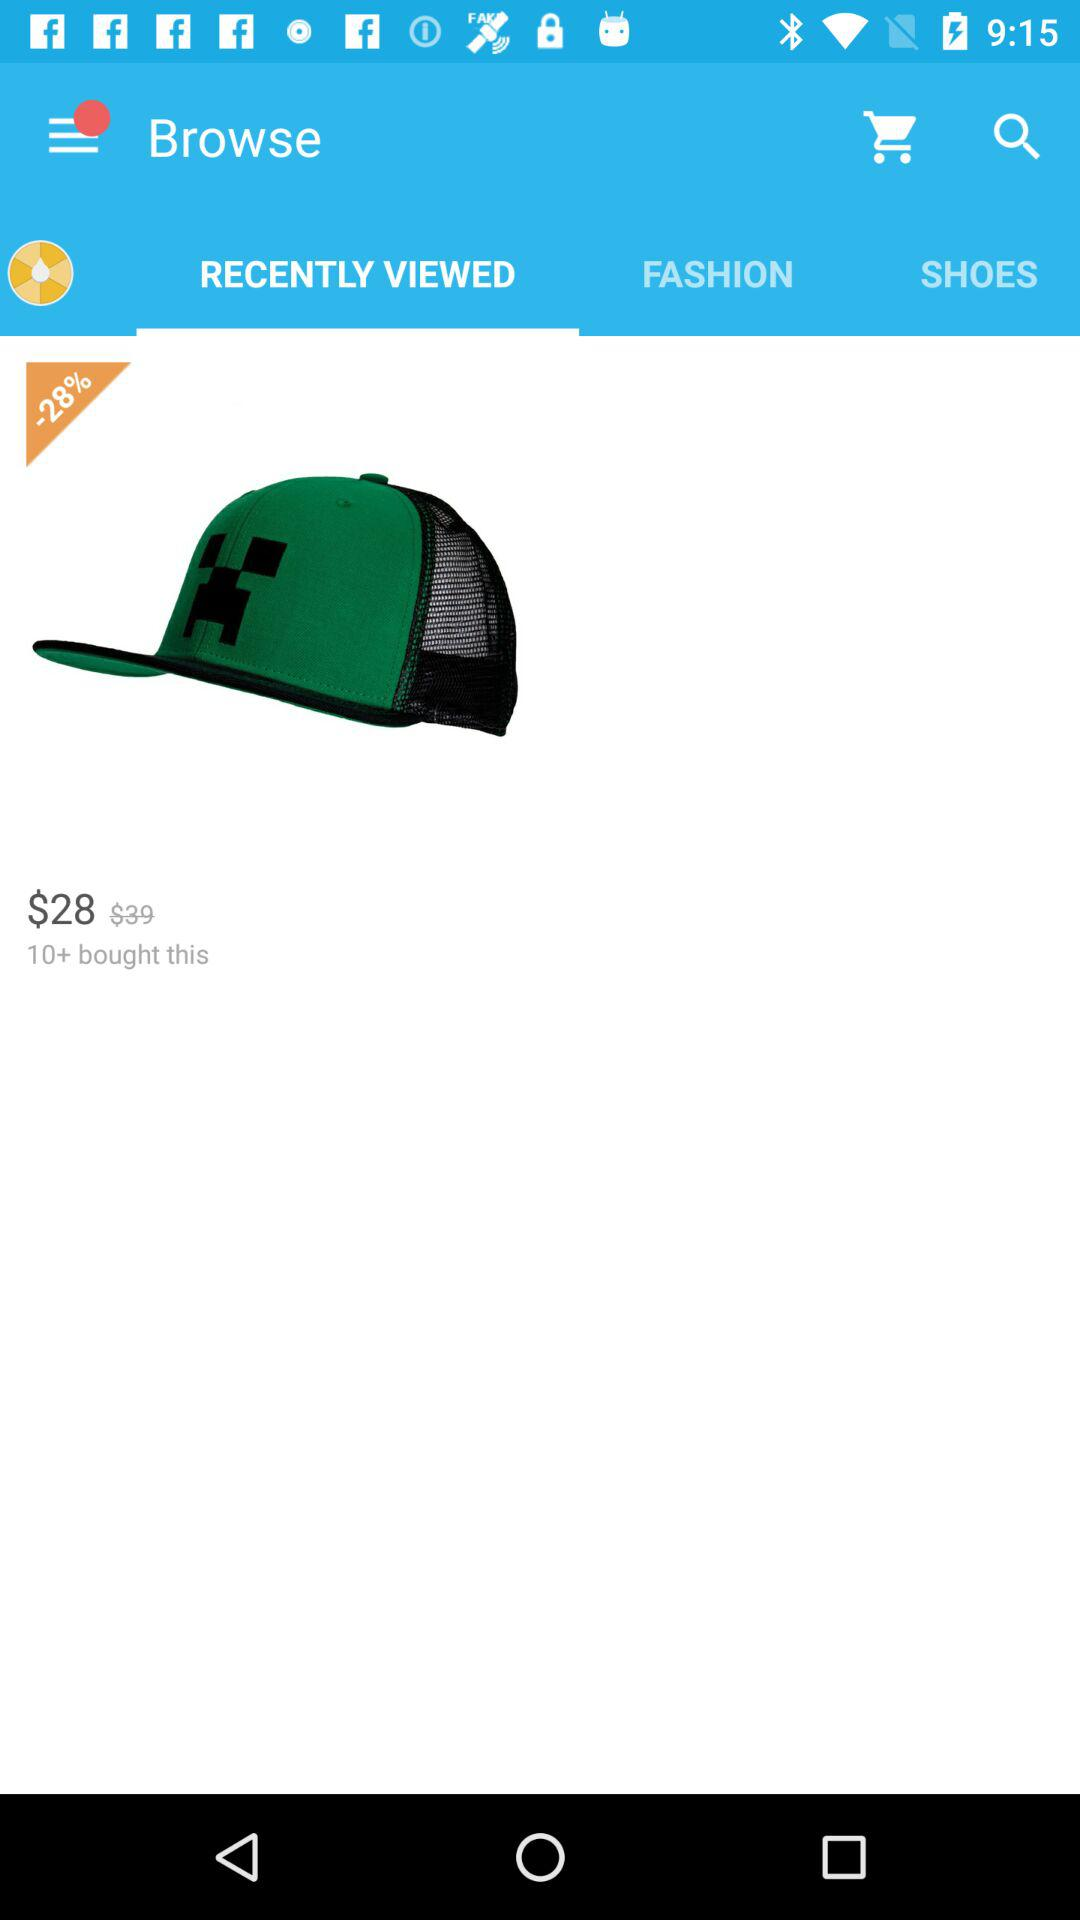What is the price difference between the original and sale price of the item?
Answer the question using a single word or phrase. $11 